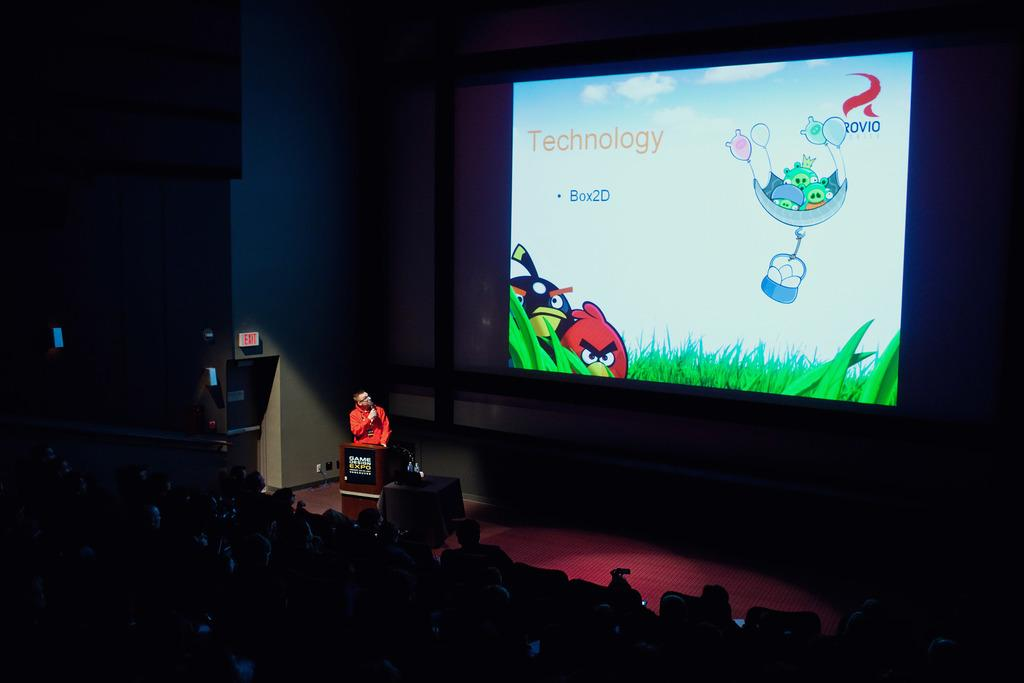Provide a one-sentence caption for the provided image. A screen at a presentation has the word Technology as its heading. 